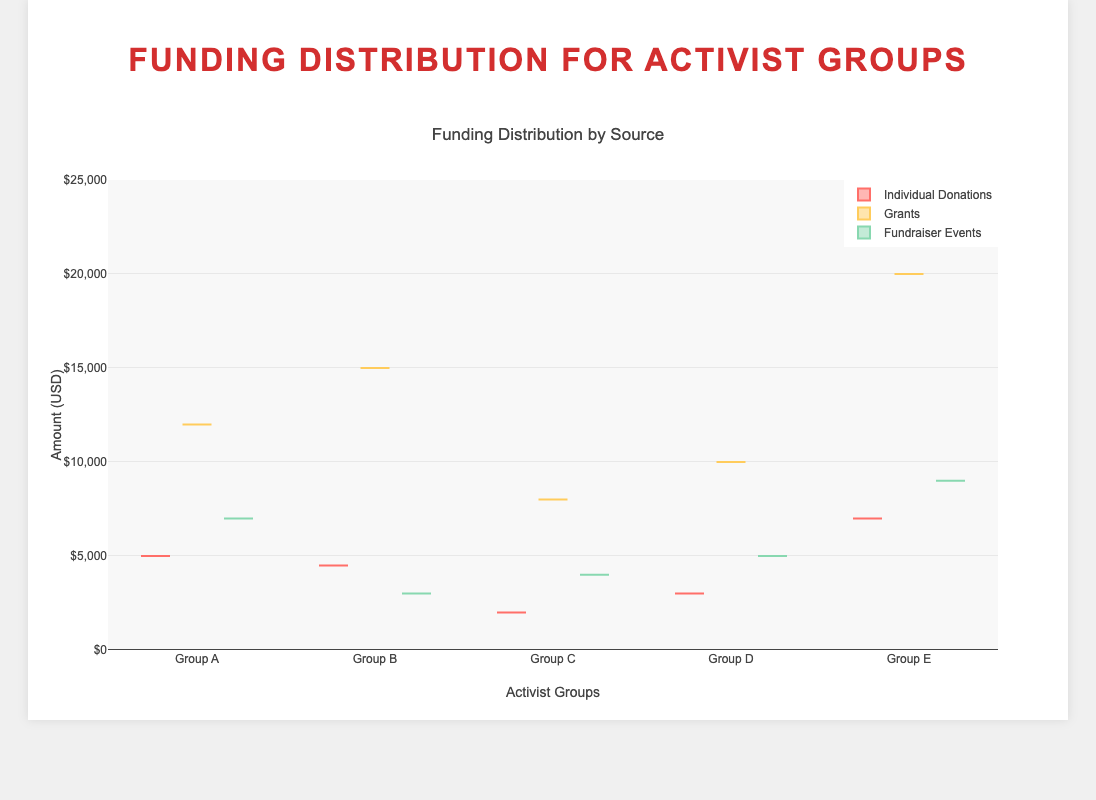What is the title of the plot? The title is displayed at the top of the plot and reads “Funding Distribution by Source”.
Answer: Funding Distribution by Source Which group received the highest amount from individual donations? The highest amount among individual donations can be seen by comparing the highest values for each group in the individual donations box plots. The highest box plot for individual donations is for Group E.
Answer: Group E What are the median amounts of grants for Group B and Group C? The median line within each box plot indicates the median amount. Check the box plots for groups B and C under the "Grants" category to find their medians. Group B’s median is close to 15000 and Group C’s median is around 8000.
Answer: Group B: 15000, Group C: 8000 How does the range of fundraiser events funding for Group A compare to Group B? The range is found by subtracting the minimum from the maximum value in each box plot. For Group A, fundraiser events range from 7000, while for Group B, they range from 3000. Thus, Group A has a wider range in the fundraiser events category.
Answer: Group A has a wider range Which source of funding has the highest upper quartile for Group D? The upper quartile is the top edge of the box. By comparing the top edges of the three boxes for Group D, grants have the highest upper quartile.
Answer: Grants What is the interquartile range (IQR) of grants for Group A? The interquartile range is the difference between the third quartile (75th percentile) and the first quartile (25th percentile) of the box. For Group A's grants, the IQR would be calculated by examining the box’s top and bottom edges.
Answer: Approximately 6000 Compare the median funding from individual donations for Group A and Group C. The median can be located by the line inside the box. Group A’s median for individual donations is around 5000, and Group C’s median is around 2000. Therefore, Group A has a higher median value for individual donations than Group C.
Answer: Group A has a higher median Which funding source exhibits the greatest variability in amounts across all groups? The variability is represented by the spread of the points in each box plot. Comparing the spread of individual donations, grants, and fundraiser events across all groups, grants show the greatest variability.
Answer: Grants 